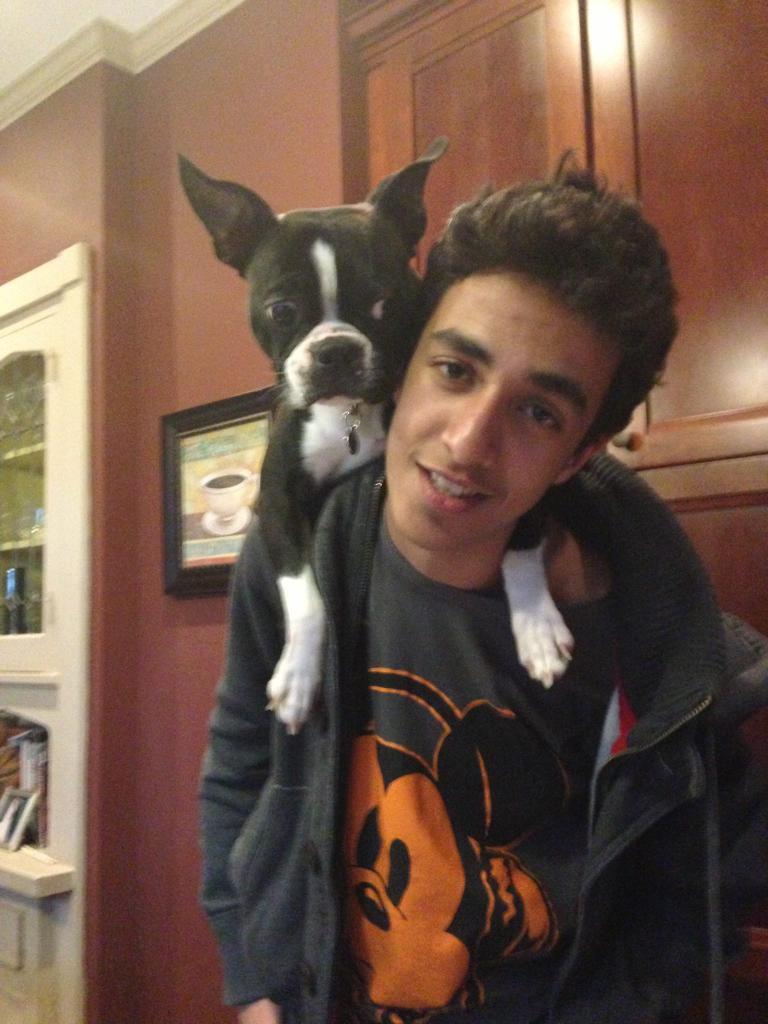Could you give a brief overview of what you see in this image? In the center of the image, we can see a rock on the person and in the background, there is a frame on the wall and we can see a cupboard and some objects. 